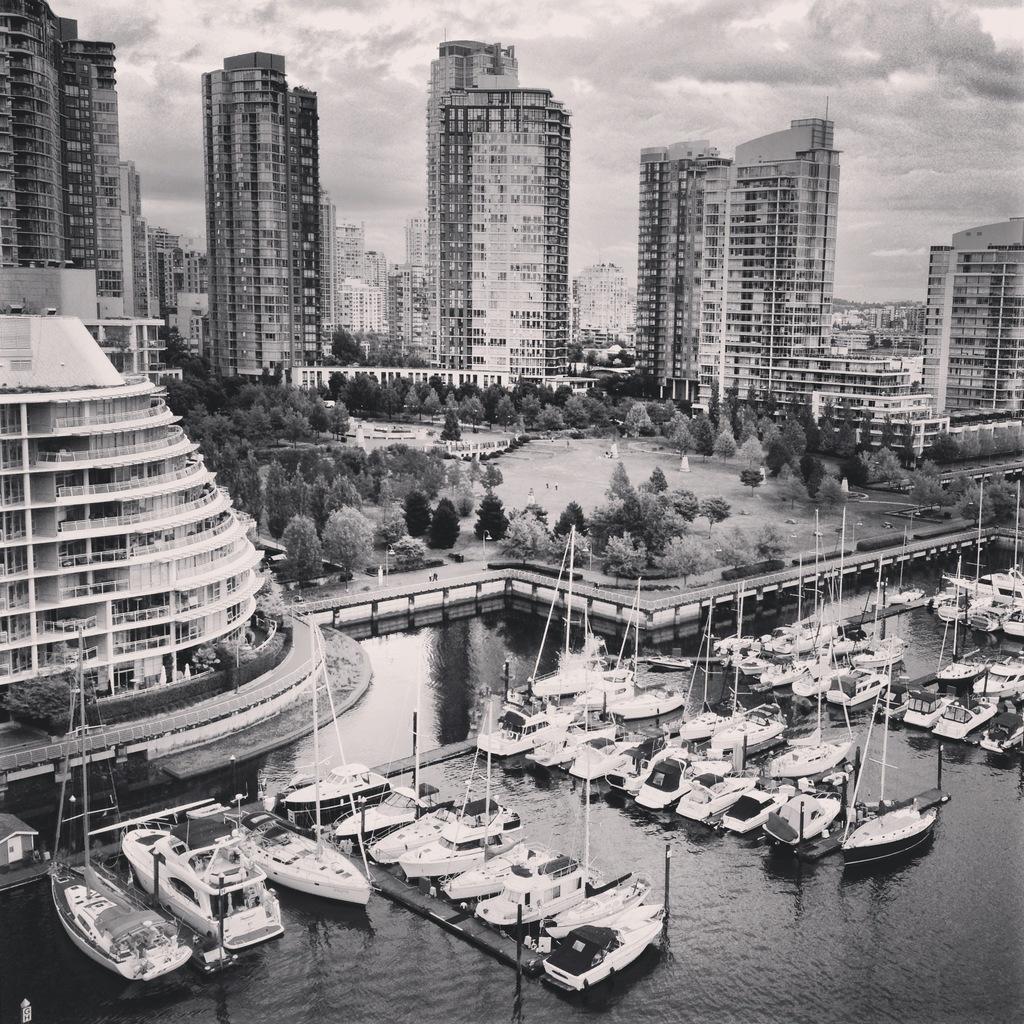Please provide a concise description of this image. In this picture I can see so many buildings, trees, ships in the water, this picture is taken from top view. 